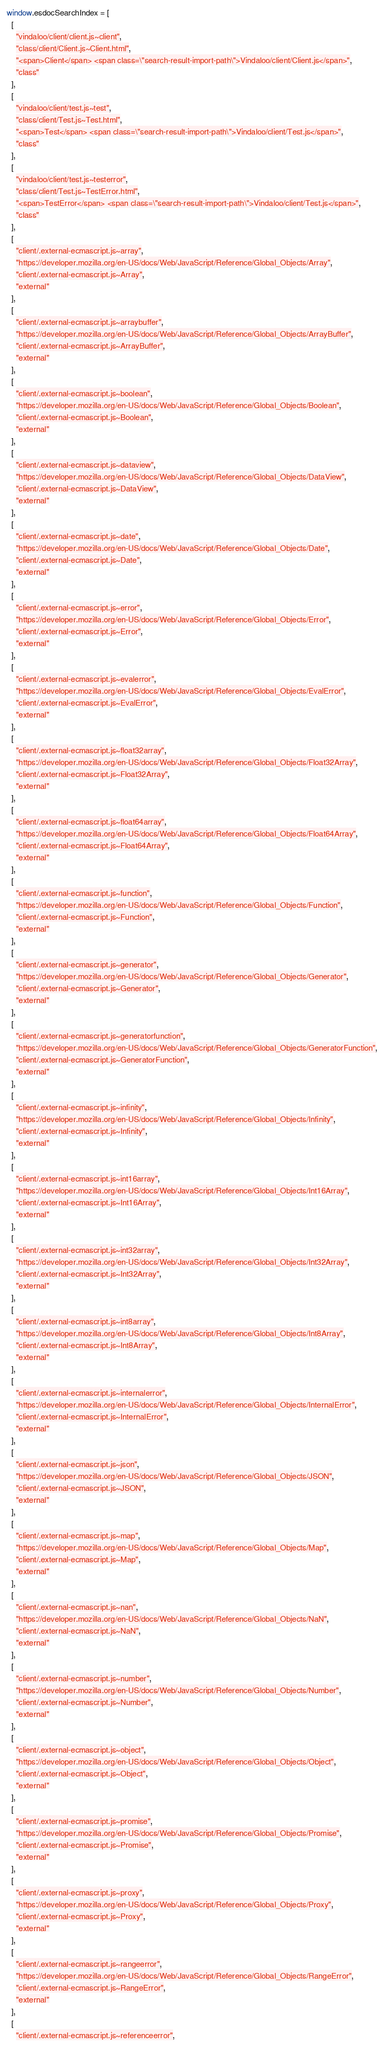Convert code to text. <code><loc_0><loc_0><loc_500><loc_500><_JavaScript_>window.esdocSearchIndex = [
  [
    "vindaloo/client/client.js~client",
    "class/client/Client.js~Client.html",
    "<span>Client</span> <span class=\"search-result-import-path\">Vindaloo/client/Client.js</span>",
    "class"
  ],
  [
    "vindaloo/client/test.js~test",
    "class/client/Test.js~Test.html",
    "<span>Test</span> <span class=\"search-result-import-path\">Vindaloo/client/Test.js</span>",
    "class"
  ],
  [
    "vindaloo/client/test.js~testerror",
    "class/client/Test.js~TestError.html",
    "<span>TestError</span> <span class=\"search-result-import-path\">Vindaloo/client/Test.js</span>",
    "class"
  ],
  [
    "client/.external-ecmascript.js~array",
    "https://developer.mozilla.org/en-US/docs/Web/JavaScript/Reference/Global_Objects/Array",
    "client/.external-ecmascript.js~Array",
    "external"
  ],
  [
    "client/.external-ecmascript.js~arraybuffer",
    "https://developer.mozilla.org/en-US/docs/Web/JavaScript/Reference/Global_Objects/ArrayBuffer",
    "client/.external-ecmascript.js~ArrayBuffer",
    "external"
  ],
  [
    "client/.external-ecmascript.js~boolean",
    "https://developer.mozilla.org/en-US/docs/Web/JavaScript/Reference/Global_Objects/Boolean",
    "client/.external-ecmascript.js~Boolean",
    "external"
  ],
  [
    "client/.external-ecmascript.js~dataview",
    "https://developer.mozilla.org/en-US/docs/Web/JavaScript/Reference/Global_Objects/DataView",
    "client/.external-ecmascript.js~DataView",
    "external"
  ],
  [
    "client/.external-ecmascript.js~date",
    "https://developer.mozilla.org/en-US/docs/Web/JavaScript/Reference/Global_Objects/Date",
    "client/.external-ecmascript.js~Date",
    "external"
  ],
  [
    "client/.external-ecmascript.js~error",
    "https://developer.mozilla.org/en-US/docs/Web/JavaScript/Reference/Global_Objects/Error",
    "client/.external-ecmascript.js~Error",
    "external"
  ],
  [
    "client/.external-ecmascript.js~evalerror",
    "https://developer.mozilla.org/en-US/docs/Web/JavaScript/Reference/Global_Objects/EvalError",
    "client/.external-ecmascript.js~EvalError",
    "external"
  ],
  [
    "client/.external-ecmascript.js~float32array",
    "https://developer.mozilla.org/en-US/docs/Web/JavaScript/Reference/Global_Objects/Float32Array",
    "client/.external-ecmascript.js~Float32Array",
    "external"
  ],
  [
    "client/.external-ecmascript.js~float64array",
    "https://developer.mozilla.org/en-US/docs/Web/JavaScript/Reference/Global_Objects/Float64Array",
    "client/.external-ecmascript.js~Float64Array",
    "external"
  ],
  [
    "client/.external-ecmascript.js~function",
    "https://developer.mozilla.org/en-US/docs/Web/JavaScript/Reference/Global_Objects/Function",
    "client/.external-ecmascript.js~Function",
    "external"
  ],
  [
    "client/.external-ecmascript.js~generator",
    "https://developer.mozilla.org/en-US/docs/Web/JavaScript/Reference/Global_Objects/Generator",
    "client/.external-ecmascript.js~Generator",
    "external"
  ],
  [
    "client/.external-ecmascript.js~generatorfunction",
    "https://developer.mozilla.org/en-US/docs/Web/JavaScript/Reference/Global_Objects/GeneratorFunction",
    "client/.external-ecmascript.js~GeneratorFunction",
    "external"
  ],
  [
    "client/.external-ecmascript.js~infinity",
    "https://developer.mozilla.org/en-US/docs/Web/JavaScript/Reference/Global_Objects/Infinity",
    "client/.external-ecmascript.js~Infinity",
    "external"
  ],
  [
    "client/.external-ecmascript.js~int16array",
    "https://developer.mozilla.org/en-US/docs/Web/JavaScript/Reference/Global_Objects/Int16Array",
    "client/.external-ecmascript.js~Int16Array",
    "external"
  ],
  [
    "client/.external-ecmascript.js~int32array",
    "https://developer.mozilla.org/en-US/docs/Web/JavaScript/Reference/Global_Objects/Int32Array",
    "client/.external-ecmascript.js~Int32Array",
    "external"
  ],
  [
    "client/.external-ecmascript.js~int8array",
    "https://developer.mozilla.org/en-US/docs/Web/JavaScript/Reference/Global_Objects/Int8Array",
    "client/.external-ecmascript.js~Int8Array",
    "external"
  ],
  [
    "client/.external-ecmascript.js~internalerror",
    "https://developer.mozilla.org/en-US/docs/Web/JavaScript/Reference/Global_Objects/InternalError",
    "client/.external-ecmascript.js~InternalError",
    "external"
  ],
  [
    "client/.external-ecmascript.js~json",
    "https://developer.mozilla.org/en-US/docs/Web/JavaScript/Reference/Global_Objects/JSON",
    "client/.external-ecmascript.js~JSON",
    "external"
  ],
  [
    "client/.external-ecmascript.js~map",
    "https://developer.mozilla.org/en-US/docs/Web/JavaScript/Reference/Global_Objects/Map",
    "client/.external-ecmascript.js~Map",
    "external"
  ],
  [
    "client/.external-ecmascript.js~nan",
    "https://developer.mozilla.org/en-US/docs/Web/JavaScript/Reference/Global_Objects/NaN",
    "client/.external-ecmascript.js~NaN",
    "external"
  ],
  [
    "client/.external-ecmascript.js~number",
    "https://developer.mozilla.org/en-US/docs/Web/JavaScript/Reference/Global_Objects/Number",
    "client/.external-ecmascript.js~Number",
    "external"
  ],
  [
    "client/.external-ecmascript.js~object",
    "https://developer.mozilla.org/en-US/docs/Web/JavaScript/Reference/Global_Objects/Object",
    "client/.external-ecmascript.js~Object",
    "external"
  ],
  [
    "client/.external-ecmascript.js~promise",
    "https://developer.mozilla.org/en-US/docs/Web/JavaScript/Reference/Global_Objects/Promise",
    "client/.external-ecmascript.js~Promise",
    "external"
  ],
  [
    "client/.external-ecmascript.js~proxy",
    "https://developer.mozilla.org/en-US/docs/Web/JavaScript/Reference/Global_Objects/Proxy",
    "client/.external-ecmascript.js~Proxy",
    "external"
  ],
  [
    "client/.external-ecmascript.js~rangeerror",
    "https://developer.mozilla.org/en-US/docs/Web/JavaScript/Reference/Global_Objects/RangeError",
    "client/.external-ecmascript.js~RangeError",
    "external"
  ],
  [
    "client/.external-ecmascript.js~referenceerror",</code> 